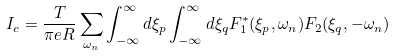Convert formula to latex. <formula><loc_0><loc_0><loc_500><loc_500>I _ { c } = \frac { T } { \pi e R } \sum _ { \omega _ { n } } \int _ { - \infty } ^ { \infty } d \xi _ { p } \int _ { - \infty } ^ { \infty } d \xi _ { q } F _ { 1 } ^ { * } ( \xi _ { p } , \omega _ { n } ) F _ { 2 } ( \xi _ { q } , - \omega _ { n } )</formula> 